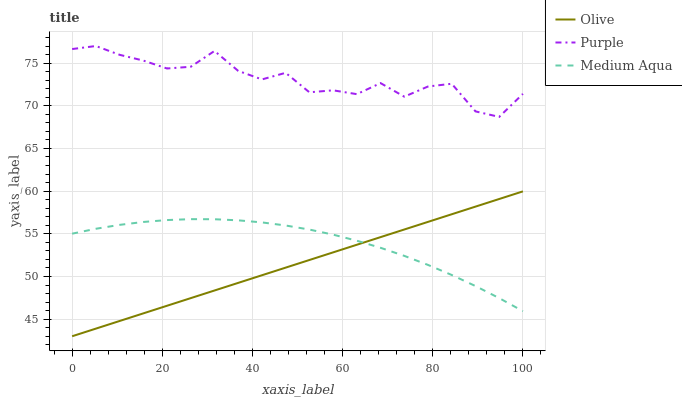Does Medium Aqua have the minimum area under the curve?
Answer yes or no. No. Does Medium Aqua have the maximum area under the curve?
Answer yes or no. No. Is Medium Aqua the smoothest?
Answer yes or no. No. Is Medium Aqua the roughest?
Answer yes or no. No. Does Medium Aqua have the lowest value?
Answer yes or no. No. Does Medium Aqua have the highest value?
Answer yes or no. No. Is Olive less than Purple?
Answer yes or no. Yes. Is Purple greater than Medium Aqua?
Answer yes or no. Yes. Does Olive intersect Purple?
Answer yes or no. No. 